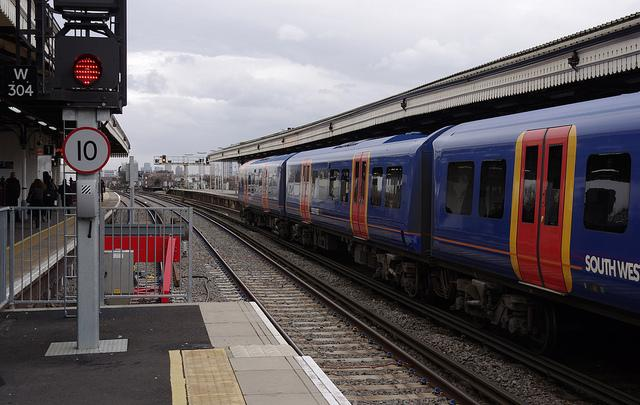What airline is advertised on the train?

Choices:
A) southwest
B) united
C) delta
D) american southwest 